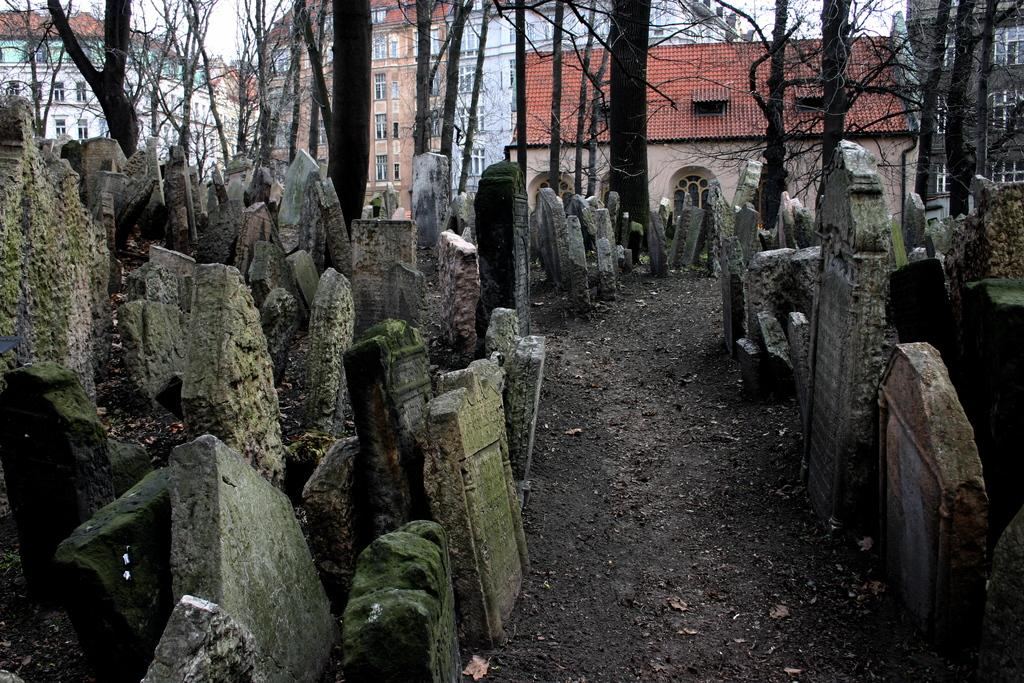What type of structures can be seen in the image? There are gravestones in the image. What is present on the ground in the image? There is soil on the floor in the image. What type of vegetation is visible in the image? There are trees in the image. What can be seen in the distance in the image? There are buildings in the background of the image. What is the condition of the sky in the image? The sky is clear in the image. What type of insurance is being sold by the coach in the image? There is no coach or insurance being sold in the image; it features gravestones, soil, trees, buildings, and a clear sky. 